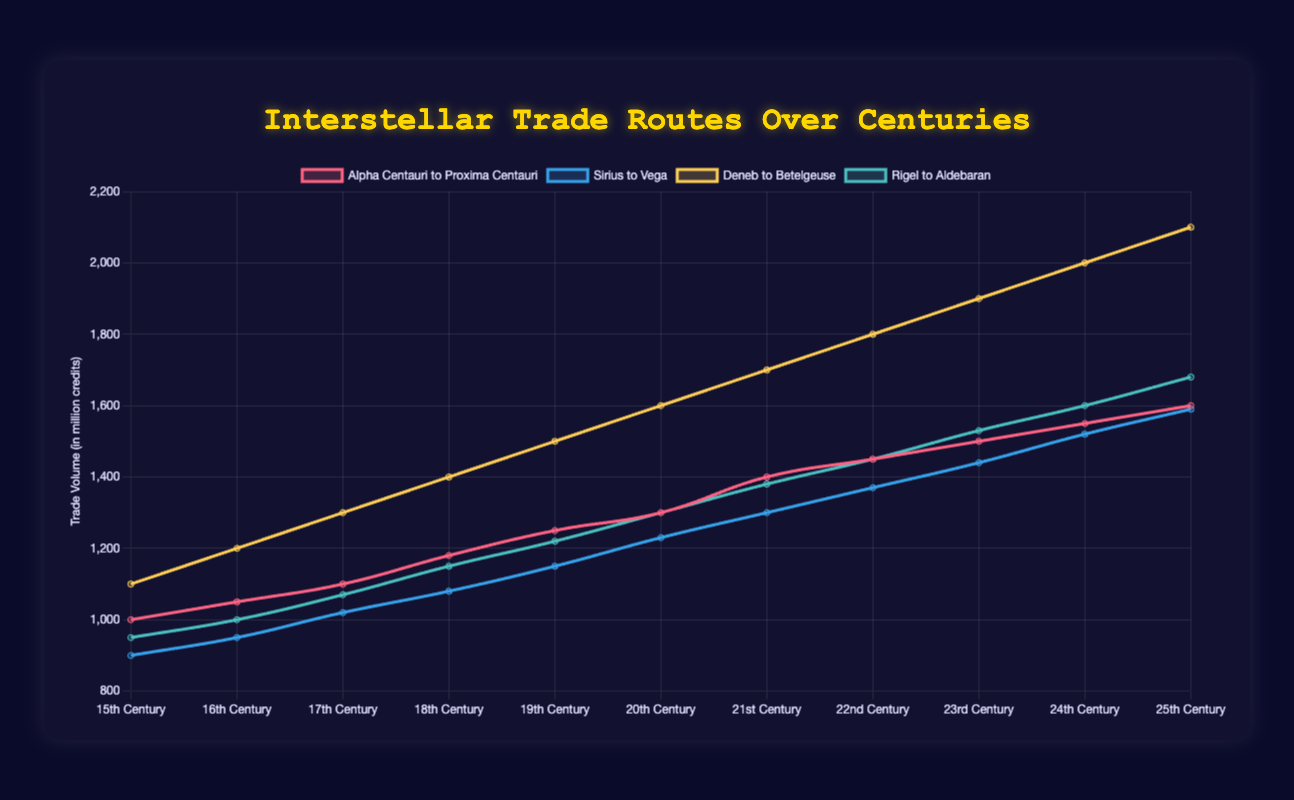How has the trade volume between Alpha Centauri and Proxima Centauri changed from the 15th to the 25th Century? The trade volume starts at 1000 million credits in the 15th Century, gradually increasing through each century, reaching 1600 million credits by the 25th Century. To find the change, subtract the 15th Century value from the 25th Century value: 1600 - 1000 = 600 million credits.
Answer: 600 million credits Which trade route demonstrated the highest increase in trade volume over the observed centuries? By observing the plot, the Deneb to Betelgeuse route shows a significant climb from 1100 million credits in the 15th Century to 2100 million credits in the 25th Century. Calculating the increase: 2100 - 1100 = 1000. This increase is higher than that of other routes.
Answer: Deneb to Betelgeuse In which century did the trade volume for Rigel to Aldebaran first surpass 1500 million credits? Looking at the line corresponding to Rigel to Aldebaran, we notice an increase to 1530 million credits in the 23rd Century, marking the first time this route surpasses 1500 million credits.
Answer: 23rd Century Compare the trade volume of Sirius to Vega and Rigel to Aldebaran in the 20th Century. Which route had a higher trade volume, and by how much? Sirius to Vega had a trade volume of 1230 million credits, and Rigel to Aldebaran had 1300 million credits. Subtracting the two values: 1300 - 1230 = 70. Rigel to Aldebaran had a higher trade volume by 70 million credits.
Answer: Rigel to Aldebaran, 70 million credits What was the average trade volume for Alpha Centauri to Proxima Centauri from the 15th Century to the 25th Century? Sum the trade volumes from each century: 1000 + 1050 + 1100 + 1180 + 1250 + 1300 + 1400 + 1450 + 1500 + 1550 + 1600 = 14380 million credits. Divide by the number of centuries (11): 14380 / 11 ≈ 1307.27.
Answer: 1307.27 million credits By what percentage did the trade volume between Deneb and Betelgeuse increase from the 15th to the 25th Century? Initial volume: 1100 million credits (15th Century), final volume: 2100 million credits (25th Century). Increase: 2100 - 1100 = 1000. Percentage increase: (1000 / 1100) * 100 ≈ 90.91%.
Answer: 90.91% Between the 18th and 21st Century, did the trade volume for Sirius to Vega increase or decrease and by how much? In the 18th Century, the volume is 1080 million credits; in the 21st Century, it is 1300 million credits. The difference: 1300 - 1080 = 220 million credits, indicating an increase.
Answer: Increase, 220 million credits During which centuries did the trade volume of Rigel to Aldebaran consistently increase without any drop? From the 15th Century to the 25th Century, the trade volume for Rigel to Aldebaran consistently increases every century without any decrease.
Answer: 15th to 25th Century What is the difference in trade volume growth between Alpha Centauri to Proxima Centauri and Sirius to Vega from the 15th to the 25th Century? For Alpha Centauri to Proxima Centauri, growth is 1600 - 1000 = 600 million credits. For Sirius to Vega, growth is 1590 - 900 = 690 million credits. Difference: 690 - 600 = 90 million credits. Sirius to Vega shows larger growth.
Answer: 90 million credits 